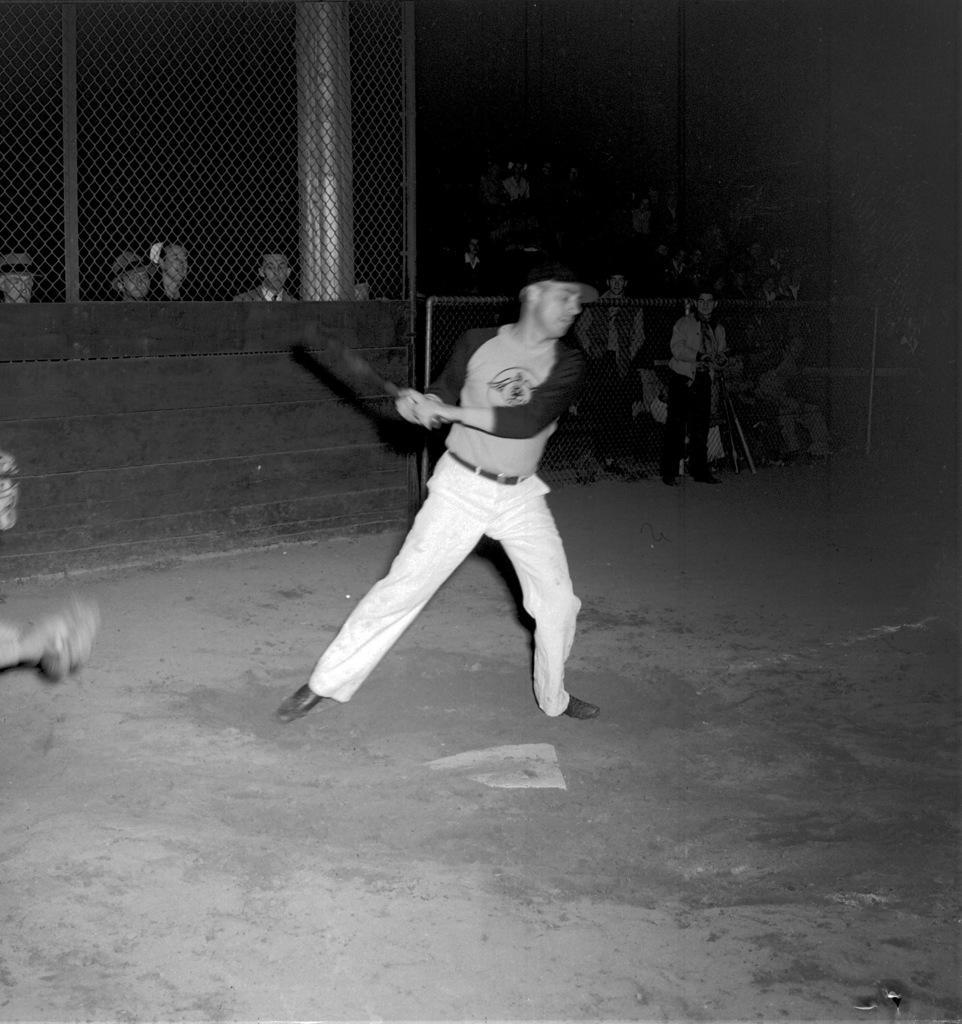Please provide a concise description of this image. In this image I can see a man is standing and I can see he is holding something. In background I can see fencing and I can see few more people are standing. I can also see this image is black and white in colour and I can see this image is little bit in dark from background. 